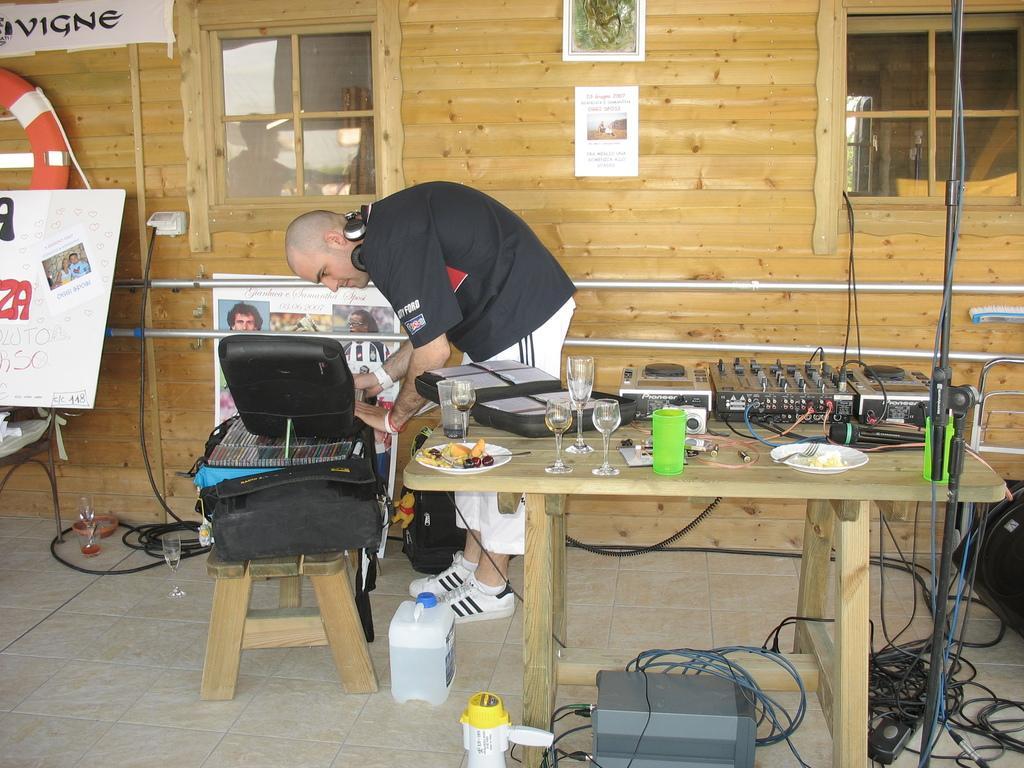In one or two sentences, can you explain what this image depicts? In this image we can see a person looking at an object and to the side we can see a table and on the table there are objects like glasses, plates with food items and some other objects and there are some wires and other things on the floor. At the background, we can see the wall with some posters with photos and text. 